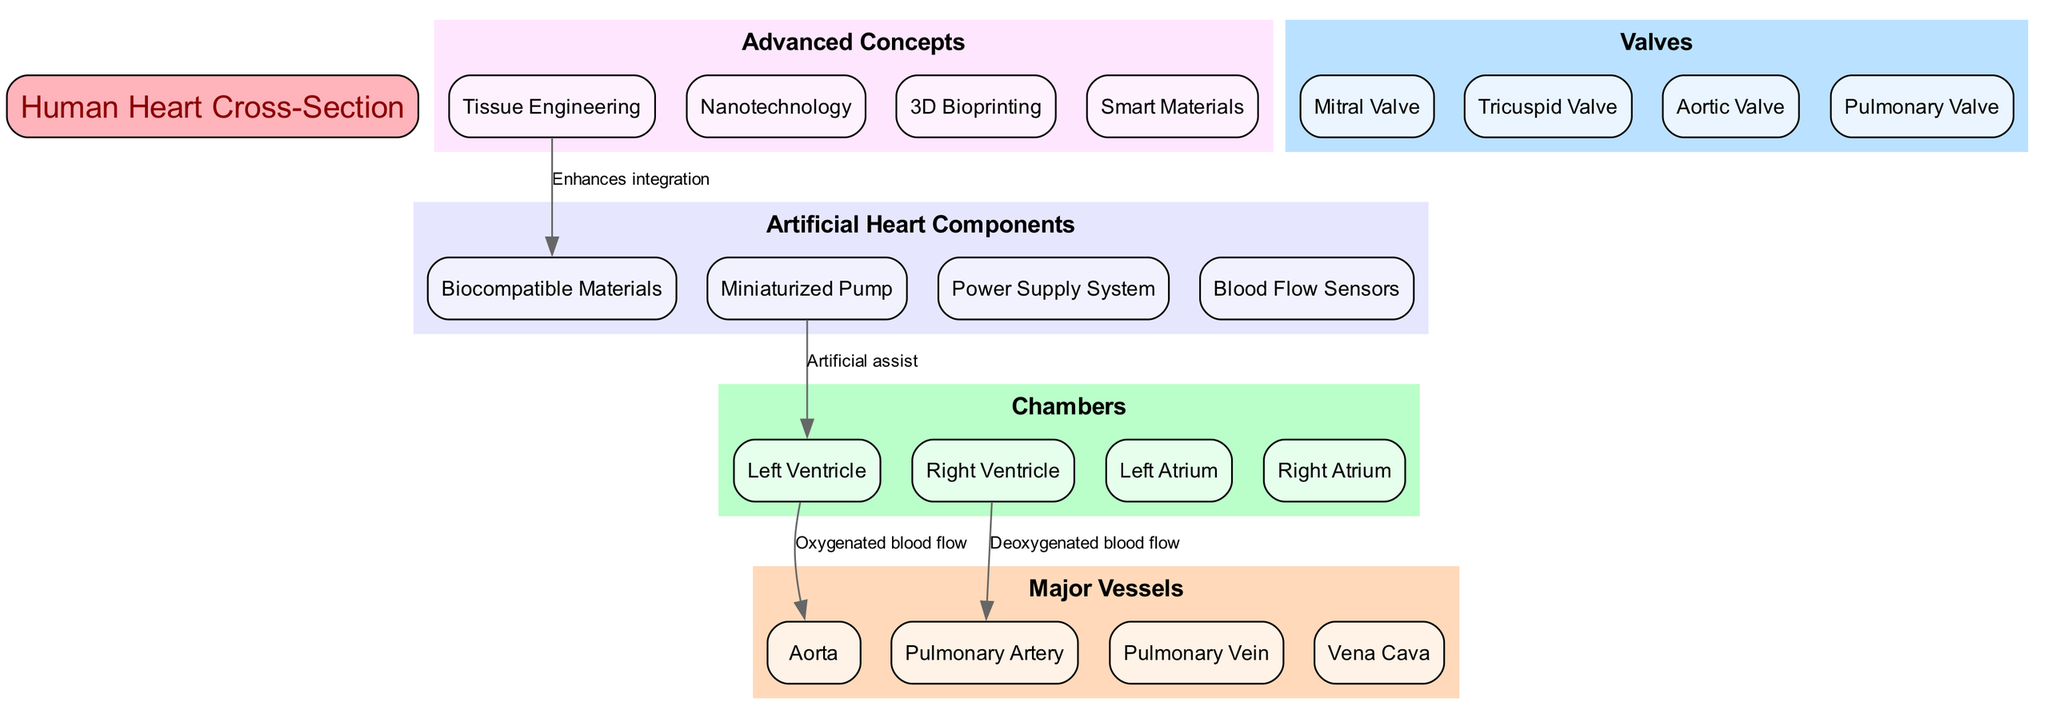What are the four chambers of the heart? The diagram specifically lists the four chambers of the heart, which includes the Left Ventricle, Right Ventricle, Left Atrium, and Right Atrium, clearly labeled in the chambers section.
Answer: Left Ventricle, Right Ventricle, Left Atrium, Right Atrium What type of blood flows through the aorta? The diagram indicates that oxygenated blood flows from the Left Ventricle through the Aorta, as noted by the connection labeled "Oxygenated blood flow."
Answer: Oxygenated blood How many valves are depicted in the diagram? The diagram categorizes four specific valves labeled as the Mitral Valve, Tricuspid Valve, Aortic Valve, and Pulmonary Valve in the valves section.
Answer: Four What components are essential for an artificial heart according to the diagram? The artificial heart components section of the diagram includes four components: Biocompatible Materials, Miniaturized Pump, Power Supply System, and Blood Flow Sensors, clearly listed.
Answer: Biocompatible Materials, Miniaturized Pump, Power Supply System, Blood Flow Sensors How does tissue engineering enhance integration with materials? The connection highlighted in the diagram demonstrates that "Tissue Engineering enhances integration" with "Biocompatible Materials," indicating a relationship between these two components.
Answer: Enhances integration What is the function of the miniaturized pump in the heart? The diagram shows that the Miniaturized Pump is connected to the Left Ventricle with the label "Artificial assist," which explains its role as an assistive component in a heart setting.
Answer: Artificial assist Which chamber connects to the pulmonary artery? The diagram shows a connection where the Right Ventricle is linked to the Pulmonary Artery, labeled "Deoxygenated blood flow," identifying the role of the Right Ventricle here.
Answer: Right Ventricle What advanced concept relates to smart materials in the heart diagram? The advanced concepts section features Smart Materials but the diagram does not provide a direct connection to another component, indicating that Smart Materials are implied as an innovative approach but without a specific linkage in this context.
Answer: Smart Materials What is the overall theme of this biomedical diagram? The central element of the diagram is focused on the "Human Heart Cross-Section," while integrating various elements essential for an artificial heart, showing a blend of biological anatomy with biomedical engineering concepts.
Answer: Human Heart Cross-Section 